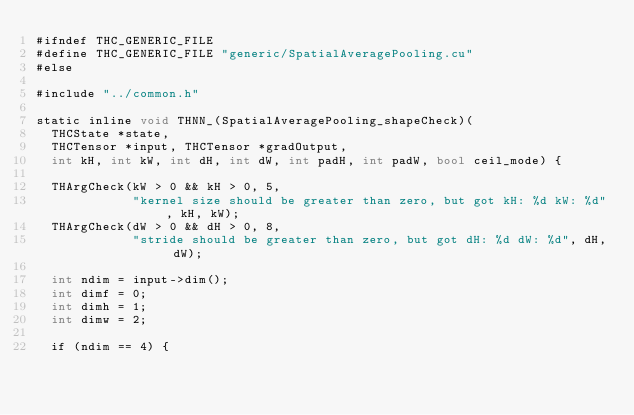<code> <loc_0><loc_0><loc_500><loc_500><_Cuda_>#ifndef THC_GENERIC_FILE
#define THC_GENERIC_FILE "generic/SpatialAveragePooling.cu"
#else

#include "../common.h"

static inline void THNN_(SpatialAveragePooling_shapeCheck)(
  THCState *state,
  THCTensor *input, THCTensor *gradOutput,
  int kH, int kW, int dH, int dW, int padH, int padW, bool ceil_mode) {

  THArgCheck(kW > 0 && kH > 0, 5,
             "kernel size should be greater than zero, but got kH: %d kW: %d", kH, kW);
  THArgCheck(dW > 0 && dH > 0, 8,
             "stride should be greater than zero, but got dH: %d dW: %d", dH, dW);

  int ndim = input->dim();
  int dimf = 0;
  int dimh = 1;
  int dimw = 2;

  if (ndim == 4) {</code> 